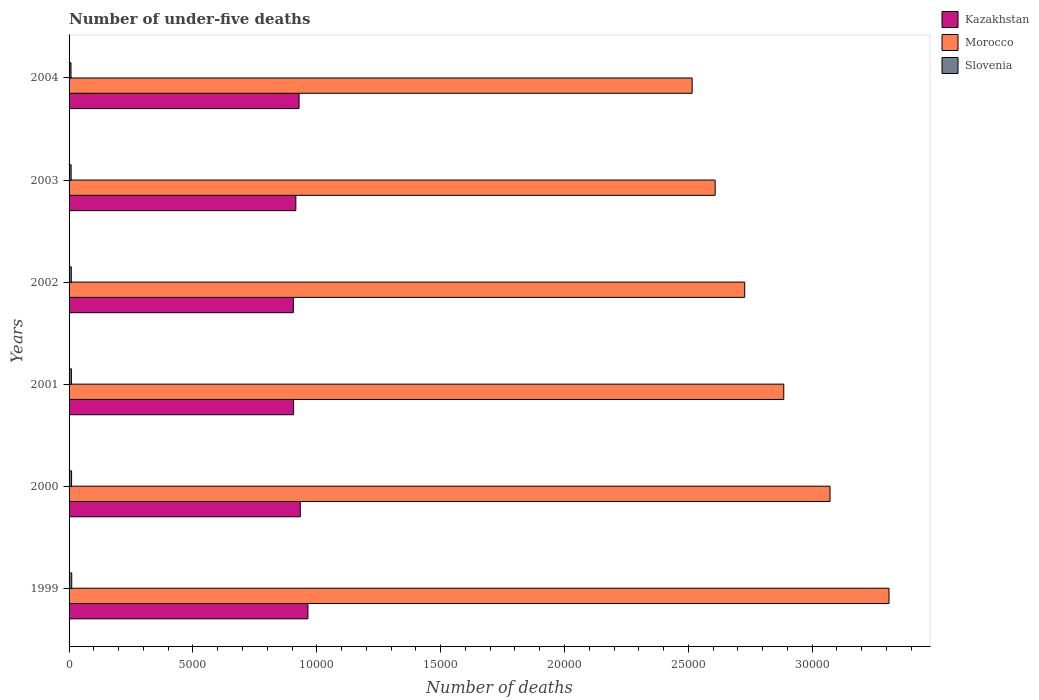How many different coloured bars are there?
Offer a very short reply. 3. How many groups of bars are there?
Provide a succinct answer. 6. Are the number of bars on each tick of the Y-axis equal?
Your response must be concise. Yes. How many bars are there on the 4th tick from the bottom?
Your answer should be very brief. 3. What is the number of under-five deaths in Kazakhstan in 2000?
Make the answer very short. 9335. Across all years, what is the maximum number of under-five deaths in Kazakhstan?
Your response must be concise. 9643. Across all years, what is the minimum number of under-five deaths in Kazakhstan?
Give a very brief answer. 9054. What is the total number of under-five deaths in Slovenia in the graph?
Provide a short and direct response. 554. What is the difference between the number of under-five deaths in Morocco in 2000 and that in 2003?
Make the answer very short. 4637. What is the difference between the number of under-five deaths in Kazakhstan in 2004 and the number of under-five deaths in Slovenia in 2002?
Your answer should be compact. 9195. What is the average number of under-five deaths in Morocco per year?
Offer a terse response. 2.85e+04. In the year 2002, what is the difference between the number of under-five deaths in Kazakhstan and number of under-five deaths in Morocco?
Give a very brief answer. -1.82e+04. In how many years, is the number of under-five deaths in Kazakhstan greater than 9000 ?
Make the answer very short. 6. What is the ratio of the number of under-five deaths in Slovenia in 2001 to that in 2002?
Your response must be concise. 1.06. Is the number of under-five deaths in Kazakhstan in 1999 less than that in 2000?
Make the answer very short. No. What is the difference between the highest and the lowest number of under-five deaths in Morocco?
Provide a short and direct response. 7948. Is the sum of the number of under-five deaths in Morocco in 1999 and 2002 greater than the maximum number of under-five deaths in Kazakhstan across all years?
Provide a short and direct response. Yes. What does the 3rd bar from the top in 2004 represents?
Offer a very short reply. Kazakhstan. What does the 1st bar from the bottom in 1999 represents?
Offer a terse response. Kazakhstan. Does the graph contain any zero values?
Make the answer very short. No. Where does the legend appear in the graph?
Ensure brevity in your answer.  Top right. What is the title of the graph?
Keep it short and to the point. Number of under-five deaths. Does "Costa Rica" appear as one of the legend labels in the graph?
Provide a succinct answer. No. What is the label or title of the X-axis?
Your answer should be compact. Number of deaths. What is the label or title of the Y-axis?
Ensure brevity in your answer.  Years. What is the Number of deaths of Kazakhstan in 1999?
Provide a short and direct response. 9643. What is the Number of deaths of Morocco in 1999?
Give a very brief answer. 3.31e+04. What is the Number of deaths in Slovenia in 1999?
Provide a succinct answer. 107. What is the Number of deaths of Kazakhstan in 2000?
Keep it short and to the point. 9335. What is the Number of deaths of Morocco in 2000?
Your answer should be compact. 3.07e+04. What is the Number of deaths in Slovenia in 2000?
Your response must be concise. 101. What is the Number of deaths of Kazakhstan in 2001?
Provide a short and direct response. 9064. What is the Number of deaths in Morocco in 2001?
Make the answer very short. 2.89e+04. What is the Number of deaths in Slovenia in 2001?
Offer a terse response. 95. What is the Number of deaths in Kazakhstan in 2002?
Offer a very short reply. 9054. What is the Number of deaths of Morocco in 2002?
Ensure brevity in your answer.  2.73e+04. What is the Number of deaths of Kazakhstan in 2003?
Offer a very short reply. 9155. What is the Number of deaths in Morocco in 2003?
Make the answer very short. 2.61e+04. What is the Number of deaths in Kazakhstan in 2004?
Provide a short and direct response. 9285. What is the Number of deaths of Morocco in 2004?
Provide a short and direct response. 2.52e+04. Across all years, what is the maximum Number of deaths of Kazakhstan?
Provide a succinct answer. 9643. Across all years, what is the maximum Number of deaths in Morocco?
Offer a terse response. 3.31e+04. Across all years, what is the maximum Number of deaths in Slovenia?
Ensure brevity in your answer.  107. Across all years, what is the minimum Number of deaths in Kazakhstan?
Offer a terse response. 9054. Across all years, what is the minimum Number of deaths of Morocco?
Offer a very short reply. 2.52e+04. What is the total Number of deaths in Kazakhstan in the graph?
Make the answer very short. 5.55e+04. What is the total Number of deaths of Morocco in the graph?
Offer a terse response. 1.71e+05. What is the total Number of deaths of Slovenia in the graph?
Your response must be concise. 554. What is the difference between the Number of deaths of Kazakhstan in 1999 and that in 2000?
Your answer should be very brief. 308. What is the difference between the Number of deaths in Morocco in 1999 and that in 2000?
Give a very brief answer. 2381. What is the difference between the Number of deaths of Kazakhstan in 1999 and that in 2001?
Your response must be concise. 579. What is the difference between the Number of deaths of Morocco in 1999 and that in 2001?
Offer a terse response. 4249. What is the difference between the Number of deaths in Kazakhstan in 1999 and that in 2002?
Your response must be concise. 589. What is the difference between the Number of deaths of Morocco in 1999 and that in 2002?
Provide a succinct answer. 5825. What is the difference between the Number of deaths in Slovenia in 1999 and that in 2002?
Your answer should be compact. 17. What is the difference between the Number of deaths of Kazakhstan in 1999 and that in 2003?
Offer a terse response. 488. What is the difference between the Number of deaths of Morocco in 1999 and that in 2003?
Provide a succinct answer. 7018. What is the difference between the Number of deaths of Kazakhstan in 1999 and that in 2004?
Your answer should be compact. 358. What is the difference between the Number of deaths in Morocco in 1999 and that in 2004?
Ensure brevity in your answer.  7948. What is the difference between the Number of deaths in Slovenia in 1999 and that in 2004?
Keep it short and to the point. 29. What is the difference between the Number of deaths in Kazakhstan in 2000 and that in 2001?
Keep it short and to the point. 271. What is the difference between the Number of deaths of Morocco in 2000 and that in 2001?
Your answer should be compact. 1868. What is the difference between the Number of deaths in Slovenia in 2000 and that in 2001?
Your answer should be compact. 6. What is the difference between the Number of deaths in Kazakhstan in 2000 and that in 2002?
Offer a terse response. 281. What is the difference between the Number of deaths in Morocco in 2000 and that in 2002?
Offer a very short reply. 3444. What is the difference between the Number of deaths in Kazakhstan in 2000 and that in 2003?
Your answer should be very brief. 180. What is the difference between the Number of deaths of Morocco in 2000 and that in 2003?
Your response must be concise. 4637. What is the difference between the Number of deaths in Slovenia in 2000 and that in 2003?
Offer a terse response. 18. What is the difference between the Number of deaths in Kazakhstan in 2000 and that in 2004?
Ensure brevity in your answer.  50. What is the difference between the Number of deaths of Morocco in 2000 and that in 2004?
Your answer should be compact. 5567. What is the difference between the Number of deaths in Morocco in 2001 and that in 2002?
Give a very brief answer. 1576. What is the difference between the Number of deaths of Slovenia in 2001 and that in 2002?
Offer a terse response. 5. What is the difference between the Number of deaths in Kazakhstan in 2001 and that in 2003?
Make the answer very short. -91. What is the difference between the Number of deaths of Morocco in 2001 and that in 2003?
Keep it short and to the point. 2769. What is the difference between the Number of deaths of Slovenia in 2001 and that in 2003?
Your response must be concise. 12. What is the difference between the Number of deaths in Kazakhstan in 2001 and that in 2004?
Your response must be concise. -221. What is the difference between the Number of deaths of Morocco in 2001 and that in 2004?
Your answer should be compact. 3699. What is the difference between the Number of deaths in Kazakhstan in 2002 and that in 2003?
Your response must be concise. -101. What is the difference between the Number of deaths in Morocco in 2002 and that in 2003?
Make the answer very short. 1193. What is the difference between the Number of deaths of Kazakhstan in 2002 and that in 2004?
Make the answer very short. -231. What is the difference between the Number of deaths of Morocco in 2002 and that in 2004?
Offer a very short reply. 2123. What is the difference between the Number of deaths in Kazakhstan in 2003 and that in 2004?
Offer a terse response. -130. What is the difference between the Number of deaths in Morocco in 2003 and that in 2004?
Your response must be concise. 930. What is the difference between the Number of deaths of Slovenia in 2003 and that in 2004?
Your answer should be compact. 5. What is the difference between the Number of deaths of Kazakhstan in 1999 and the Number of deaths of Morocco in 2000?
Offer a terse response. -2.11e+04. What is the difference between the Number of deaths in Kazakhstan in 1999 and the Number of deaths in Slovenia in 2000?
Give a very brief answer. 9542. What is the difference between the Number of deaths of Morocco in 1999 and the Number of deaths of Slovenia in 2000?
Make the answer very short. 3.30e+04. What is the difference between the Number of deaths in Kazakhstan in 1999 and the Number of deaths in Morocco in 2001?
Make the answer very short. -1.92e+04. What is the difference between the Number of deaths of Kazakhstan in 1999 and the Number of deaths of Slovenia in 2001?
Your answer should be very brief. 9548. What is the difference between the Number of deaths of Morocco in 1999 and the Number of deaths of Slovenia in 2001?
Your answer should be very brief. 3.30e+04. What is the difference between the Number of deaths in Kazakhstan in 1999 and the Number of deaths in Morocco in 2002?
Provide a short and direct response. -1.76e+04. What is the difference between the Number of deaths in Kazakhstan in 1999 and the Number of deaths in Slovenia in 2002?
Ensure brevity in your answer.  9553. What is the difference between the Number of deaths of Morocco in 1999 and the Number of deaths of Slovenia in 2002?
Offer a terse response. 3.30e+04. What is the difference between the Number of deaths in Kazakhstan in 1999 and the Number of deaths in Morocco in 2003?
Your answer should be very brief. -1.64e+04. What is the difference between the Number of deaths of Kazakhstan in 1999 and the Number of deaths of Slovenia in 2003?
Keep it short and to the point. 9560. What is the difference between the Number of deaths in Morocco in 1999 and the Number of deaths in Slovenia in 2003?
Ensure brevity in your answer.  3.30e+04. What is the difference between the Number of deaths of Kazakhstan in 1999 and the Number of deaths of Morocco in 2004?
Make the answer very short. -1.55e+04. What is the difference between the Number of deaths in Kazakhstan in 1999 and the Number of deaths in Slovenia in 2004?
Your response must be concise. 9565. What is the difference between the Number of deaths of Morocco in 1999 and the Number of deaths of Slovenia in 2004?
Offer a very short reply. 3.30e+04. What is the difference between the Number of deaths of Kazakhstan in 2000 and the Number of deaths of Morocco in 2001?
Give a very brief answer. -1.95e+04. What is the difference between the Number of deaths in Kazakhstan in 2000 and the Number of deaths in Slovenia in 2001?
Your answer should be compact. 9240. What is the difference between the Number of deaths of Morocco in 2000 and the Number of deaths of Slovenia in 2001?
Your answer should be very brief. 3.06e+04. What is the difference between the Number of deaths of Kazakhstan in 2000 and the Number of deaths of Morocco in 2002?
Offer a terse response. -1.79e+04. What is the difference between the Number of deaths in Kazakhstan in 2000 and the Number of deaths in Slovenia in 2002?
Your answer should be very brief. 9245. What is the difference between the Number of deaths of Morocco in 2000 and the Number of deaths of Slovenia in 2002?
Your response must be concise. 3.06e+04. What is the difference between the Number of deaths of Kazakhstan in 2000 and the Number of deaths of Morocco in 2003?
Provide a short and direct response. -1.67e+04. What is the difference between the Number of deaths in Kazakhstan in 2000 and the Number of deaths in Slovenia in 2003?
Keep it short and to the point. 9252. What is the difference between the Number of deaths in Morocco in 2000 and the Number of deaths in Slovenia in 2003?
Provide a short and direct response. 3.06e+04. What is the difference between the Number of deaths of Kazakhstan in 2000 and the Number of deaths of Morocco in 2004?
Provide a short and direct response. -1.58e+04. What is the difference between the Number of deaths of Kazakhstan in 2000 and the Number of deaths of Slovenia in 2004?
Make the answer very short. 9257. What is the difference between the Number of deaths in Morocco in 2000 and the Number of deaths in Slovenia in 2004?
Give a very brief answer. 3.06e+04. What is the difference between the Number of deaths in Kazakhstan in 2001 and the Number of deaths in Morocco in 2002?
Your answer should be very brief. -1.82e+04. What is the difference between the Number of deaths of Kazakhstan in 2001 and the Number of deaths of Slovenia in 2002?
Your response must be concise. 8974. What is the difference between the Number of deaths of Morocco in 2001 and the Number of deaths of Slovenia in 2002?
Your answer should be very brief. 2.88e+04. What is the difference between the Number of deaths in Kazakhstan in 2001 and the Number of deaths in Morocco in 2003?
Your answer should be compact. -1.70e+04. What is the difference between the Number of deaths in Kazakhstan in 2001 and the Number of deaths in Slovenia in 2003?
Your response must be concise. 8981. What is the difference between the Number of deaths in Morocco in 2001 and the Number of deaths in Slovenia in 2003?
Your answer should be very brief. 2.88e+04. What is the difference between the Number of deaths in Kazakhstan in 2001 and the Number of deaths in Morocco in 2004?
Offer a very short reply. -1.61e+04. What is the difference between the Number of deaths of Kazakhstan in 2001 and the Number of deaths of Slovenia in 2004?
Offer a very short reply. 8986. What is the difference between the Number of deaths in Morocco in 2001 and the Number of deaths in Slovenia in 2004?
Ensure brevity in your answer.  2.88e+04. What is the difference between the Number of deaths in Kazakhstan in 2002 and the Number of deaths in Morocco in 2003?
Your answer should be very brief. -1.70e+04. What is the difference between the Number of deaths of Kazakhstan in 2002 and the Number of deaths of Slovenia in 2003?
Provide a succinct answer. 8971. What is the difference between the Number of deaths in Morocco in 2002 and the Number of deaths in Slovenia in 2003?
Provide a succinct answer. 2.72e+04. What is the difference between the Number of deaths of Kazakhstan in 2002 and the Number of deaths of Morocco in 2004?
Offer a very short reply. -1.61e+04. What is the difference between the Number of deaths of Kazakhstan in 2002 and the Number of deaths of Slovenia in 2004?
Keep it short and to the point. 8976. What is the difference between the Number of deaths of Morocco in 2002 and the Number of deaths of Slovenia in 2004?
Ensure brevity in your answer.  2.72e+04. What is the difference between the Number of deaths in Kazakhstan in 2003 and the Number of deaths in Morocco in 2004?
Offer a terse response. -1.60e+04. What is the difference between the Number of deaths in Kazakhstan in 2003 and the Number of deaths in Slovenia in 2004?
Make the answer very short. 9077. What is the difference between the Number of deaths of Morocco in 2003 and the Number of deaths of Slovenia in 2004?
Offer a very short reply. 2.60e+04. What is the average Number of deaths in Kazakhstan per year?
Your answer should be very brief. 9256. What is the average Number of deaths in Morocco per year?
Keep it short and to the point. 2.85e+04. What is the average Number of deaths of Slovenia per year?
Provide a short and direct response. 92.33. In the year 1999, what is the difference between the Number of deaths in Kazakhstan and Number of deaths in Morocco?
Offer a very short reply. -2.35e+04. In the year 1999, what is the difference between the Number of deaths of Kazakhstan and Number of deaths of Slovenia?
Offer a terse response. 9536. In the year 1999, what is the difference between the Number of deaths in Morocco and Number of deaths in Slovenia?
Offer a very short reply. 3.30e+04. In the year 2000, what is the difference between the Number of deaths in Kazakhstan and Number of deaths in Morocco?
Keep it short and to the point. -2.14e+04. In the year 2000, what is the difference between the Number of deaths in Kazakhstan and Number of deaths in Slovenia?
Your response must be concise. 9234. In the year 2000, what is the difference between the Number of deaths in Morocco and Number of deaths in Slovenia?
Offer a terse response. 3.06e+04. In the year 2001, what is the difference between the Number of deaths of Kazakhstan and Number of deaths of Morocco?
Offer a very short reply. -1.98e+04. In the year 2001, what is the difference between the Number of deaths in Kazakhstan and Number of deaths in Slovenia?
Ensure brevity in your answer.  8969. In the year 2001, what is the difference between the Number of deaths of Morocco and Number of deaths of Slovenia?
Provide a short and direct response. 2.88e+04. In the year 2002, what is the difference between the Number of deaths of Kazakhstan and Number of deaths of Morocco?
Provide a short and direct response. -1.82e+04. In the year 2002, what is the difference between the Number of deaths of Kazakhstan and Number of deaths of Slovenia?
Ensure brevity in your answer.  8964. In the year 2002, what is the difference between the Number of deaths in Morocco and Number of deaths in Slovenia?
Offer a terse response. 2.72e+04. In the year 2003, what is the difference between the Number of deaths of Kazakhstan and Number of deaths of Morocco?
Ensure brevity in your answer.  -1.69e+04. In the year 2003, what is the difference between the Number of deaths of Kazakhstan and Number of deaths of Slovenia?
Provide a succinct answer. 9072. In the year 2003, what is the difference between the Number of deaths in Morocco and Number of deaths in Slovenia?
Provide a short and direct response. 2.60e+04. In the year 2004, what is the difference between the Number of deaths of Kazakhstan and Number of deaths of Morocco?
Your response must be concise. -1.59e+04. In the year 2004, what is the difference between the Number of deaths in Kazakhstan and Number of deaths in Slovenia?
Your answer should be compact. 9207. In the year 2004, what is the difference between the Number of deaths in Morocco and Number of deaths in Slovenia?
Give a very brief answer. 2.51e+04. What is the ratio of the Number of deaths of Kazakhstan in 1999 to that in 2000?
Ensure brevity in your answer.  1.03. What is the ratio of the Number of deaths of Morocco in 1999 to that in 2000?
Your answer should be very brief. 1.08. What is the ratio of the Number of deaths of Slovenia in 1999 to that in 2000?
Ensure brevity in your answer.  1.06. What is the ratio of the Number of deaths of Kazakhstan in 1999 to that in 2001?
Provide a succinct answer. 1.06. What is the ratio of the Number of deaths of Morocco in 1999 to that in 2001?
Provide a succinct answer. 1.15. What is the ratio of the Number of deaths of Slovenia in 1999 to that in 2001?
Provide a short and direct response. 1.13. What is the ratio of the Number of deaths of Kazakhstan in 1999 to that in 2002?
Your answer should be compact. 1.07. What is the ratio of the Number of deaths of Morocco in 1999 to that in 2002?
Provide a succinct answer. 1.21. What is the ratio of the Number of deaths of Slovenia in 1999 to that in 2002?
Your answer should be compact. 1.19. What is the ratio of the Number of deaths in Kazakhstan in 1999 to that in 2003?
Offer a terse response. 1.05. What is the ratio of the Number of deaths in Morocco in 1999 to that in 2003?
Your response must be concise. 1.27. What is the ratio of the Number of deaths in Slovenia in 1999 to that in 2003?
Offer a very short reply. 1.29. What is the ratio of the Number of deaths of Kazakhstan in 1999 to that in 2004?
Offer a very short reply. 1.04. What is the ratio of the Number of deaths in Morocco in 1999 to that in 2004?
Keep it short and to the point. 1.32. What is the ratio of the Number of deaths in Slovenia in 1999 to that in 2004?
Provide a short and direct response. 1.37. What is the ratio of the Number of deaths in Kazakhstan in 2000 to that in 2001?
Keep it short and to the point. 1.03. What is the ratio of the Number of deaths in Morocco in 2000 to that in 2001?
Your response must be concise. 1.06. What is the ratio of the Number of deaths of Slovenia in 2000 to that in 2001?
Keep it short and to the point. 1.06. What is the ratio of the Number of deaths of Kazakhstan in 2000 to that in 2002?
Give a very brief answer. 1.03. What is the ratio of the Number of deaths in Morocco in 2000 to that in 2002?
Make the answer very short. 1.13. What is the ratio of the Number of deaths in Slovenia in 2000 to that in 2002?
Offer a terse response. 1.12. What is the ratio of the Number of deaths of Kazakhstan in 2000 to that in 2003?
Offer a very short reply. 1.02. What is the ratio of the Number of deaths of Morocco in 2000 to that in 2003?
Ensure brevity in your answer.  1.18. What is the ratio of the Number of deaths in Slovenia in 2000 to that in 2003?
Your answer should be very brief. 1.22. What is the ratio of the Number of deaths in Kazakhstan in 2000 to that in 2004?
Keep it short and to the point. 1.01. What is the ratio of the Number of deaths of Morocco in 2000 to that in 2004?
Keep it short and to the point. 1.22. What is the ratio of the Number of deaths in Slovenia in 2000 to that in 2004?
Your answer should be very brief. 1.29. What is the ratio of the Number of deaths in Morocco in 2001 to that in 2002?
Your response must be concise. 1.06. What is the ratio of the Number of deaths in Slovenia in 2001 to that in 2002?
Provide a short and direct response. 1.06. What is the ratio of the Number of deaths in Kazakhstan in 2001 to that in 2003?
Your response must be concise. 0.99. What is the ratio of the Number of deaths of Morocco in 2001 to that in 2003?
Keep it short and to the point. 1.11. What is the ratio of the Number of deaths of Slovenia in 2001 to that in 2003?
Your response must be concise. 1.14. What is the ratio of the Number of deaths of Kazakhstan in 2001 to that in 2004?
Your answer should be compact. 0.98. What is the ratio of the Number of deaths of Morocco in 2001 to that in 2004?
Your response must be concise. 1.15. What is the ratio of the Number of deaths in Slovenia in 2001 to that in 2004?
Provide a succinct answer. 1.22. What is the ratio of the Number of deaths in Morocco in 2002 to that in 2003?
Make the answer very short. 1.05. What is the ratio of the Number of deaths in Slovenia in 2002 to that in 2003?
Your answer should be very brief. 1.08. What is the ratio of the Number of deaths of Kazakhstan in 2002 to that in 2004?
Your answer should be very brief. 0.98. What is the ratio of the Number of deaths of Morocco in 2002 to that in 2004?
Ensure brevity in your answer.  1.08. What is the ratio of the Number of deaths in Slovenia in 2002 to that in 2004?
Offer a terse response. 1.15. What is the ratio of the Number of deaths in Slovenia in 2003 to that in 2004?
Give a very brief answer. 1.06. What is the difference between the highest and the second highest Number of deaths of Kazakhstan?
Offer a very short reply. 308. What is the difference between the highest and the second highest Number of deaths in Morocco?
Provide a succinct answer. 2381. What is the difference between the highest and the lowest Number of deaths in Kazakhstan?
Offer a terse response. 589. What is the difference between the highest and the lowest Number of deaths of Morocco?
Your response must be concise. 7948. What is the difference between the highest and the lowest Number of deaths of Slovenia?
Your answer should be compact. 29. 